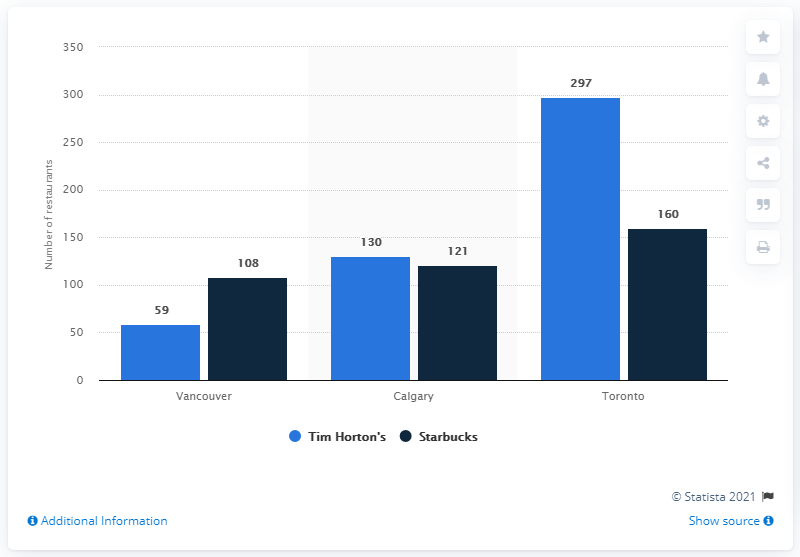Is there a significant difference in the number of Starbucks locations between the cities shown? Yes, there is a notable difference. Toronto leads with 160 Starbucks stores, which is a substantial margin compared to Calgary's 121 and Vancouver's 108 locations. 